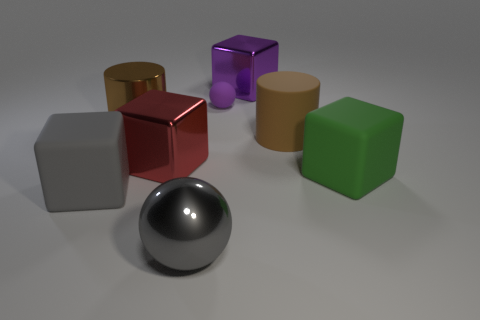Subtract all purple blocks. How many blocks are left? 3 Subtract 1 blocks. How many blocks are left? 3 Subtract all purple blocks. How many blocks are left? 3 Add 1 large red things. How many objects exist? 9 Subtract all spheres. How many objects are left? 6 Subtract all red blocks. Subtract all yellow spheres. How many blocks are left? 3 Subtract all metal things. Subtract all large purple cubes. How many objects are left? 3 Add 6 green matte things. How many green matte things are left? 7 Add 1 tiny purple rubber cylinders. How many tiny purple rubber cylinders exist? 1 Subtract 0 brown balls. How many objects are left? 8 